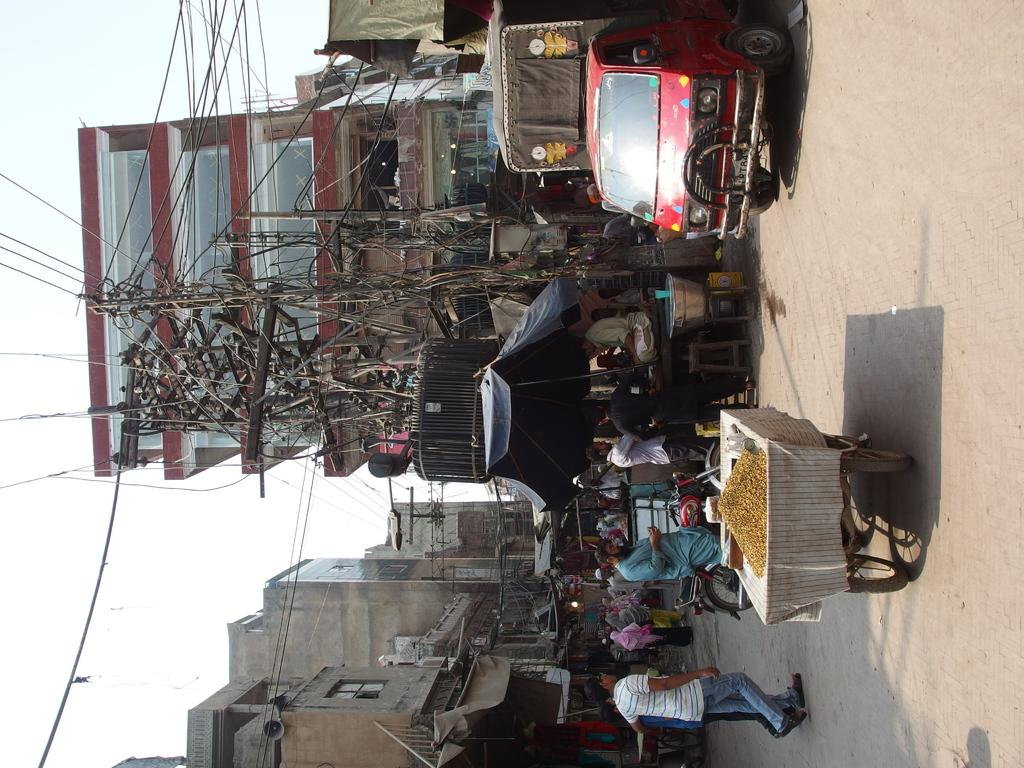What is the main object in the image? There is a transformer in the image. What else can be seen in the image besides the transformer? There are two poles, wires, people, vehicles, and buildings in the background of the image. What are the people doing in the image? The presence of people in the image suggests they might be working or passing by the transformer and poles. What type of structures are visible in the background? There are buildings in the background of the image. What type of yam is being used to repair the transformer in the image? There is no yam present in the image, and yams are not used for repairing transformers. 